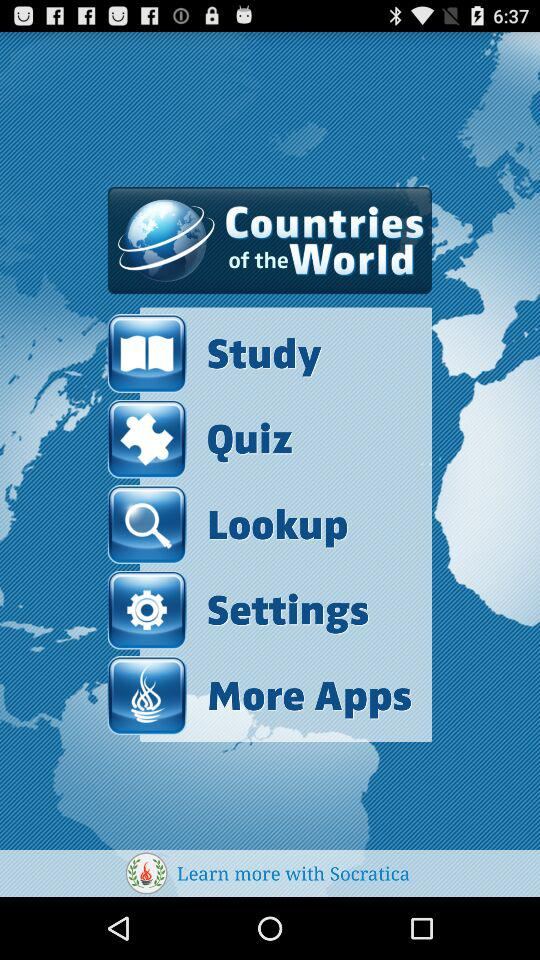What is the application name? The application name is "Countries of the World". 